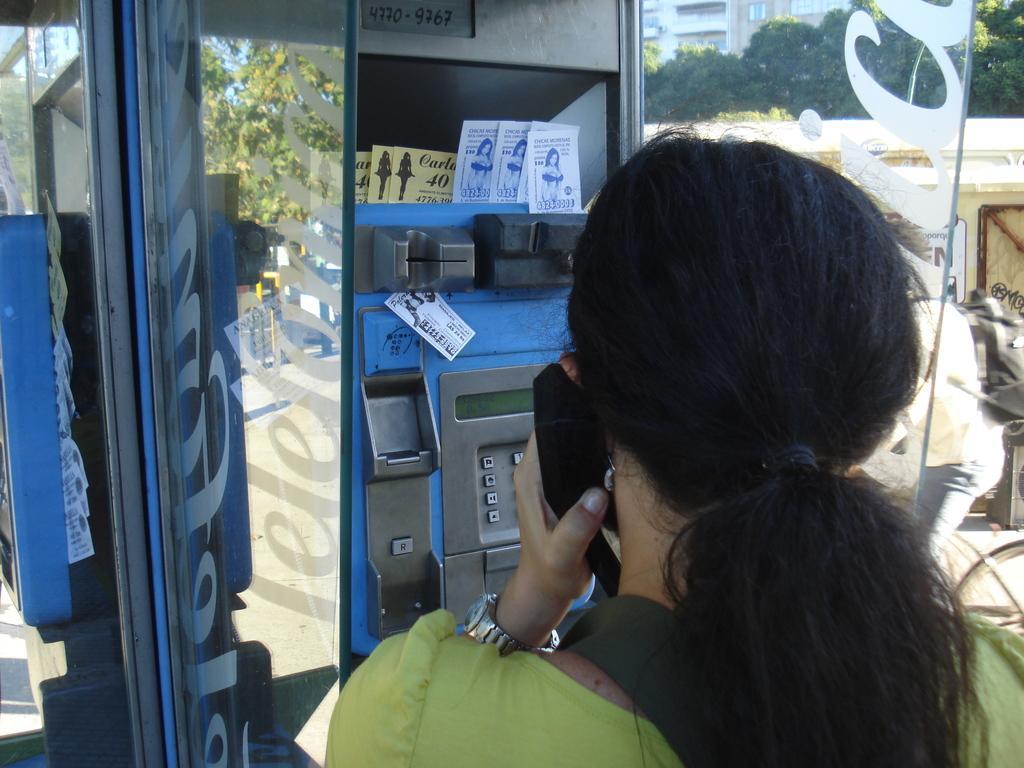Describe this image in one or two sentences. In the picture I can see a woman standing and speaking in front of a telephone booth and there are trees and a building in the right corner. 